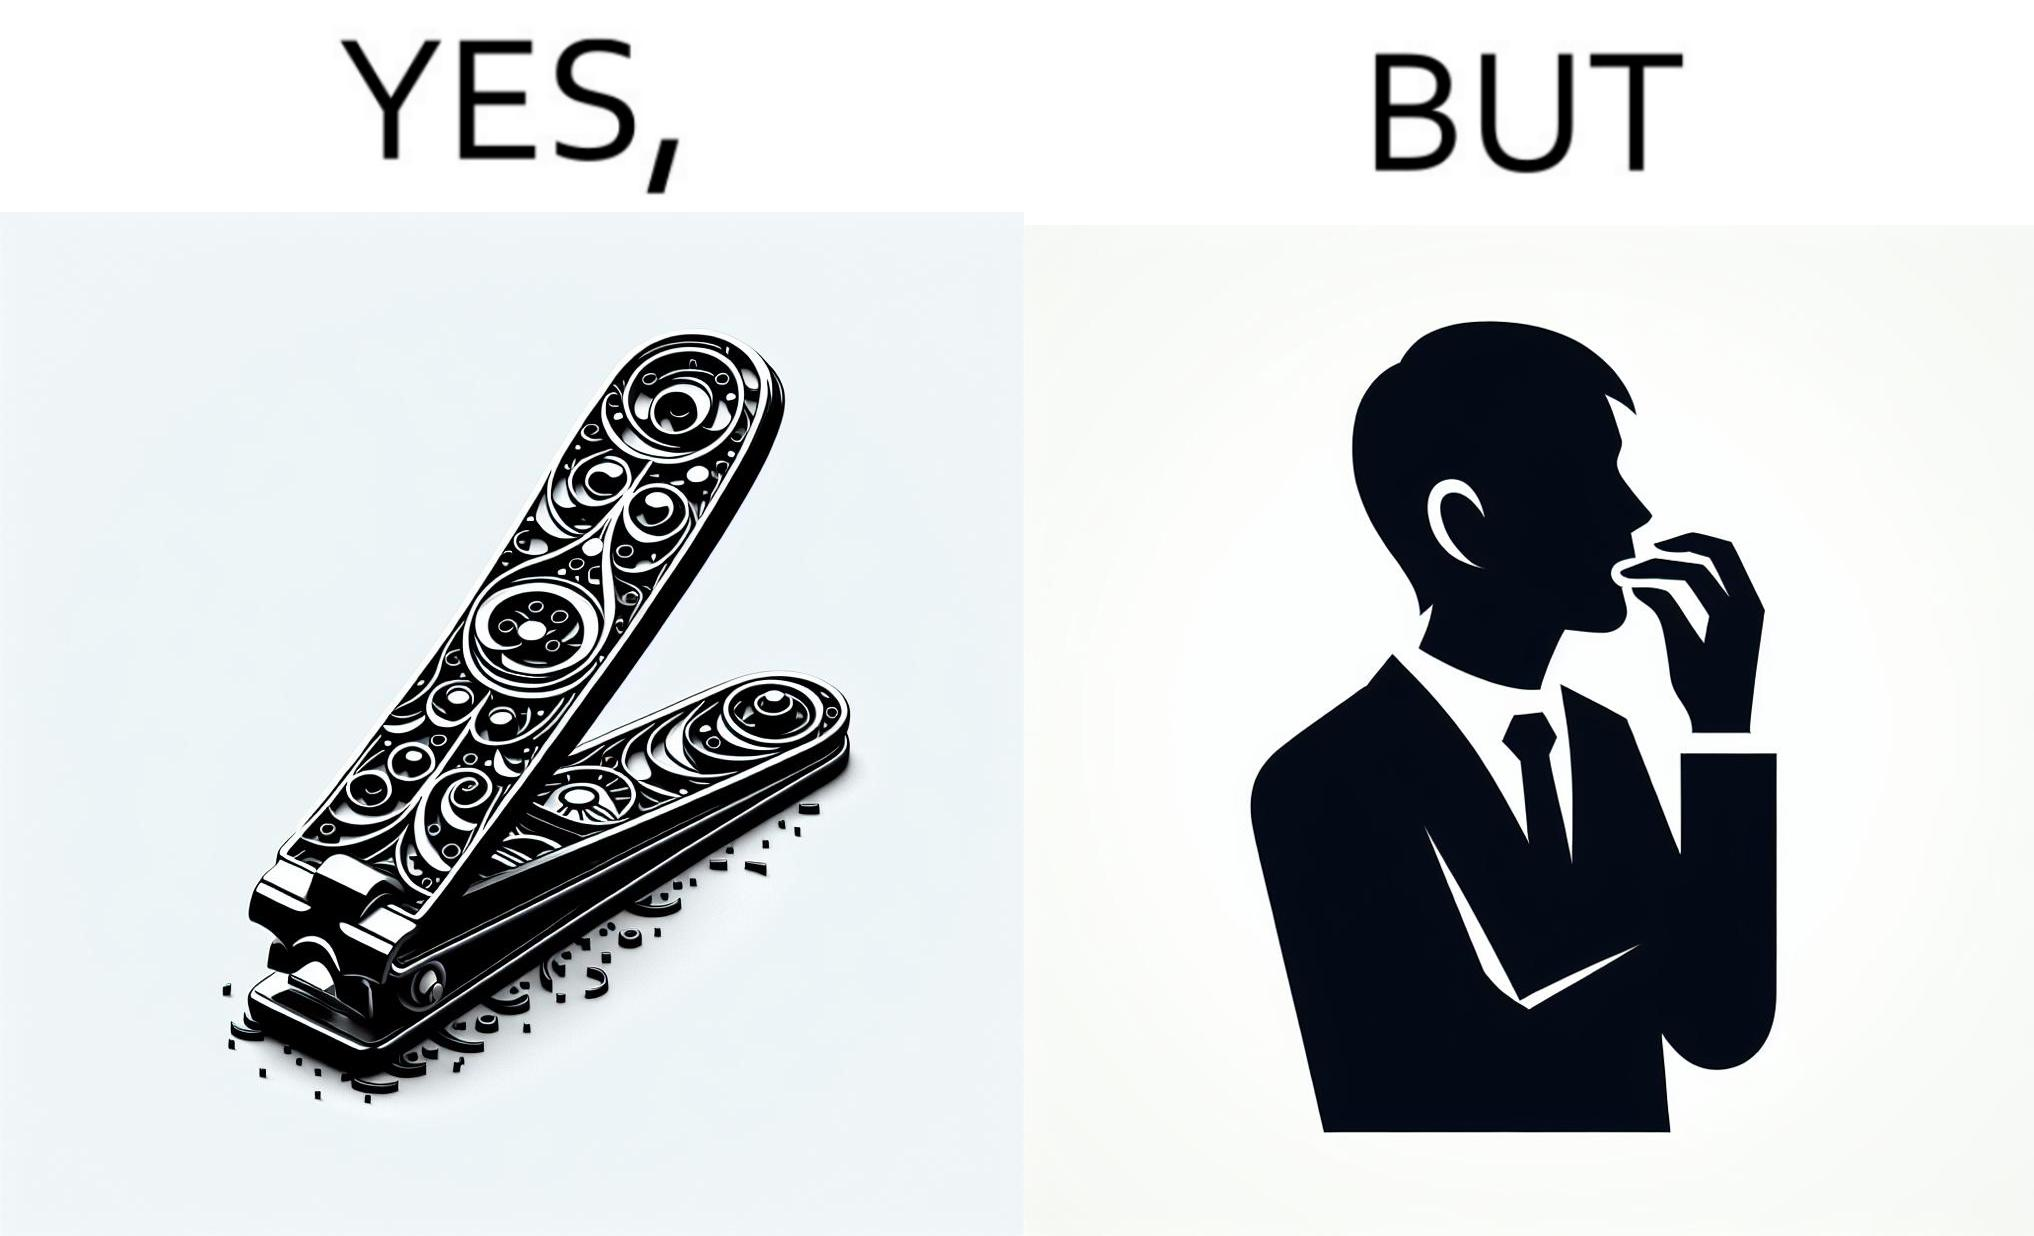Is this a satirical image? Yes, this image is satirical. 